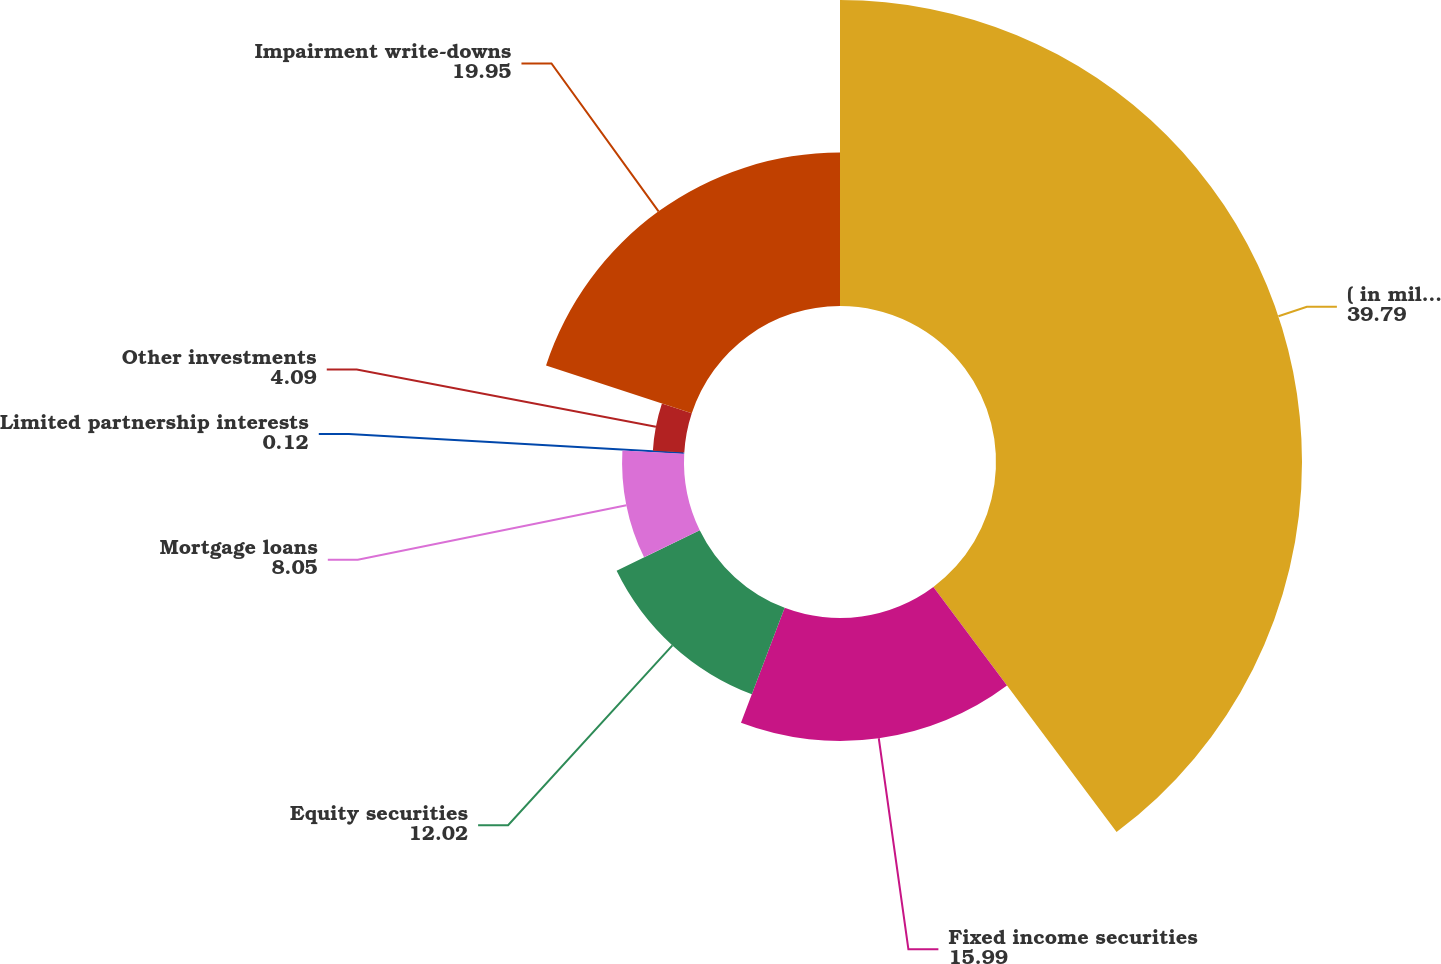Convert chart. <chart><loc_0><loc_0><loc_500><loc_500><pie_chart><fcel>( in millions)<fcel>Fixed income securities<fcel>Equity securities<fcel>Mortgage loans<fcel>Limited partnership interests<fcel>Other investments<fcel>Impairment write-downs<nl><fcel>39.79%<fcel>15.99%<fcel>12.02%<fcel>8.05%<fcel>0.12%<fcel>4.09%<fcel>19.95%<nl></chart> 